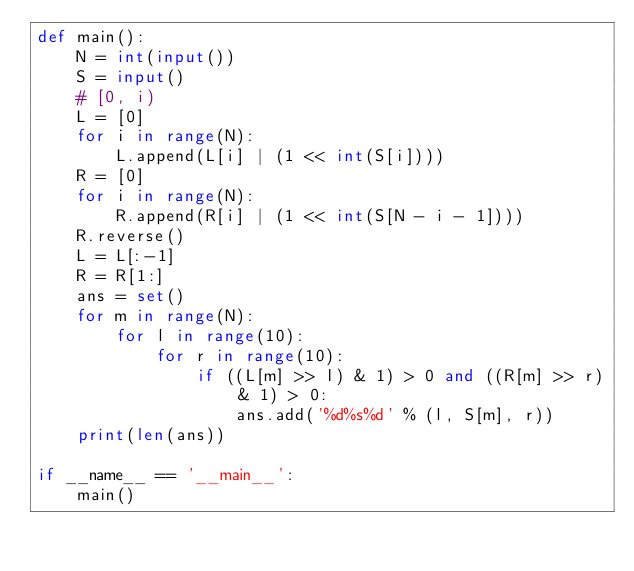Convert code to text. <code><loc_0><loc_0><loc_500><loc_500><_Python_>def main():
    N = int(input())
    S = input()
    # [0, i)
    L = [0]
    for i in range(N):
        L.append(L[i] | (1 << int(S[i])))
    R = [0]
    for i in range(N):
        R.append(R[i] | (1 << int(S[N - i - 1])))
    R.reverse()
    L = L[:-1]
    R = R[1:]
    ans = set()
    for m in range(N):
        for l in range(10):
            for r in range(10):
                if ((L[m] >> l) & 1) > 0 and ((R[m] >> r) & 1) > 0:
                    ans.add('%d%s%d' % (l, S[m], r))
    print(len(ans))

if __name__ == '__main__':
    main()
</code> 